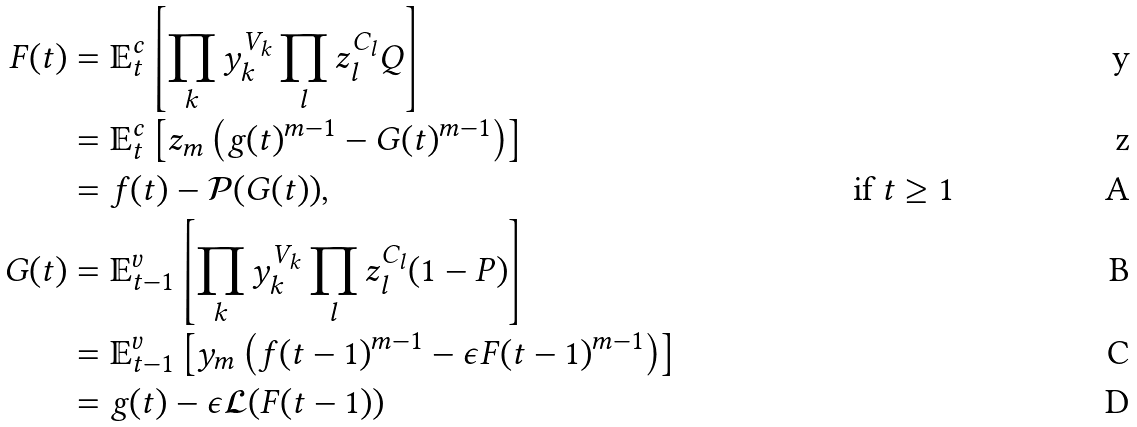<formula> <loc_0><loc_0><loc_500><loc_500>F ( t ) & = \mathbb { E } _ { t } ^ { c } \left [ \prod _ { k } y _ { k } ^ { V _ { k } } \prod _ { l } z _ { l } ^ { C _ { l } } Q \right ] \\ & = \mathbb { E } _ { t } ^ { c } \left [ z _ { m } \left ( g ( t ) ^ { m - 1 } - G ( t ) ^ { m - 1 } \right ) \right ] \\ & = f ( t ) - \mathcal { P } ( G ( t ) ) \text {,} & \text {if } t \geq 1 \\ G ( t ) & = \mathbb { E } _ { t - 1 } ^ { v } \left [ \prod _ { k } y _ { k } ^ { V _ { k } } \prod _ { l } z _ { l } ^ { C _ { l } } ( 1 - P ) \right ] \\ & = \mathbb { E } _ { t - 1 } ^ { v } \left [ y _ { m } \left ( f ( t - 1 ) ^ { m - 1 } - \epsilon F ( t - 1 ) ^ { m - 1 } \right ) \right ] \\ & = g ( t ) - \epsilon \mathcal { L } ( F ( t - 1 ) )</formula> 